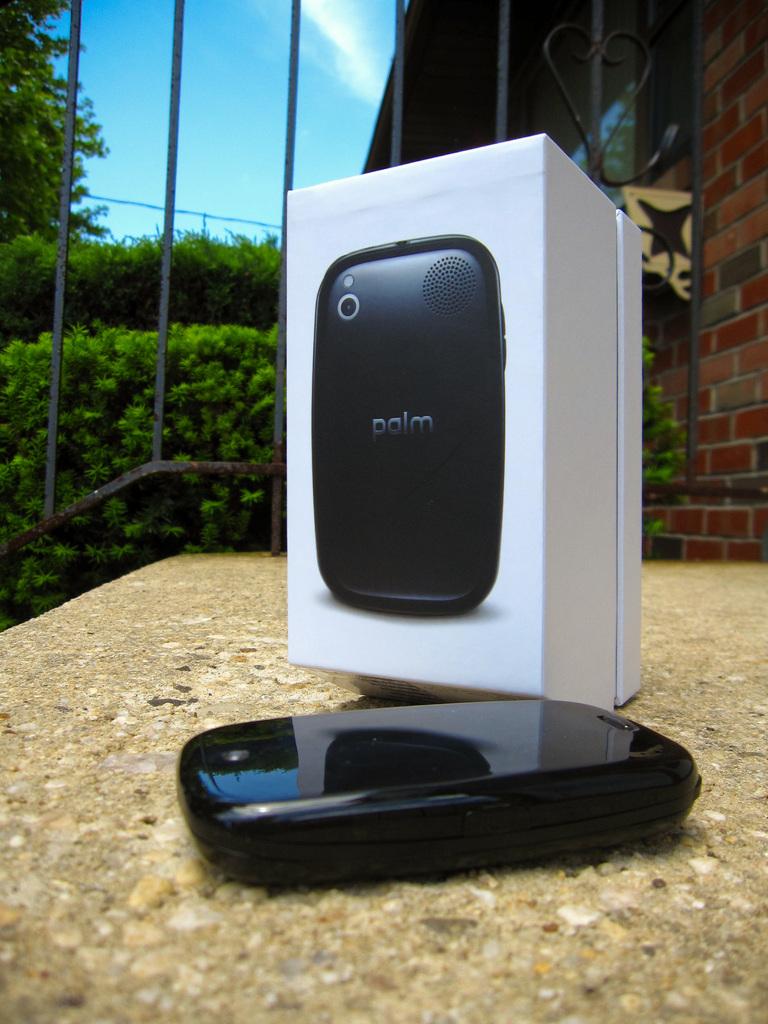Whatr brand is th ephone?
Offer a terse response. Palm. 